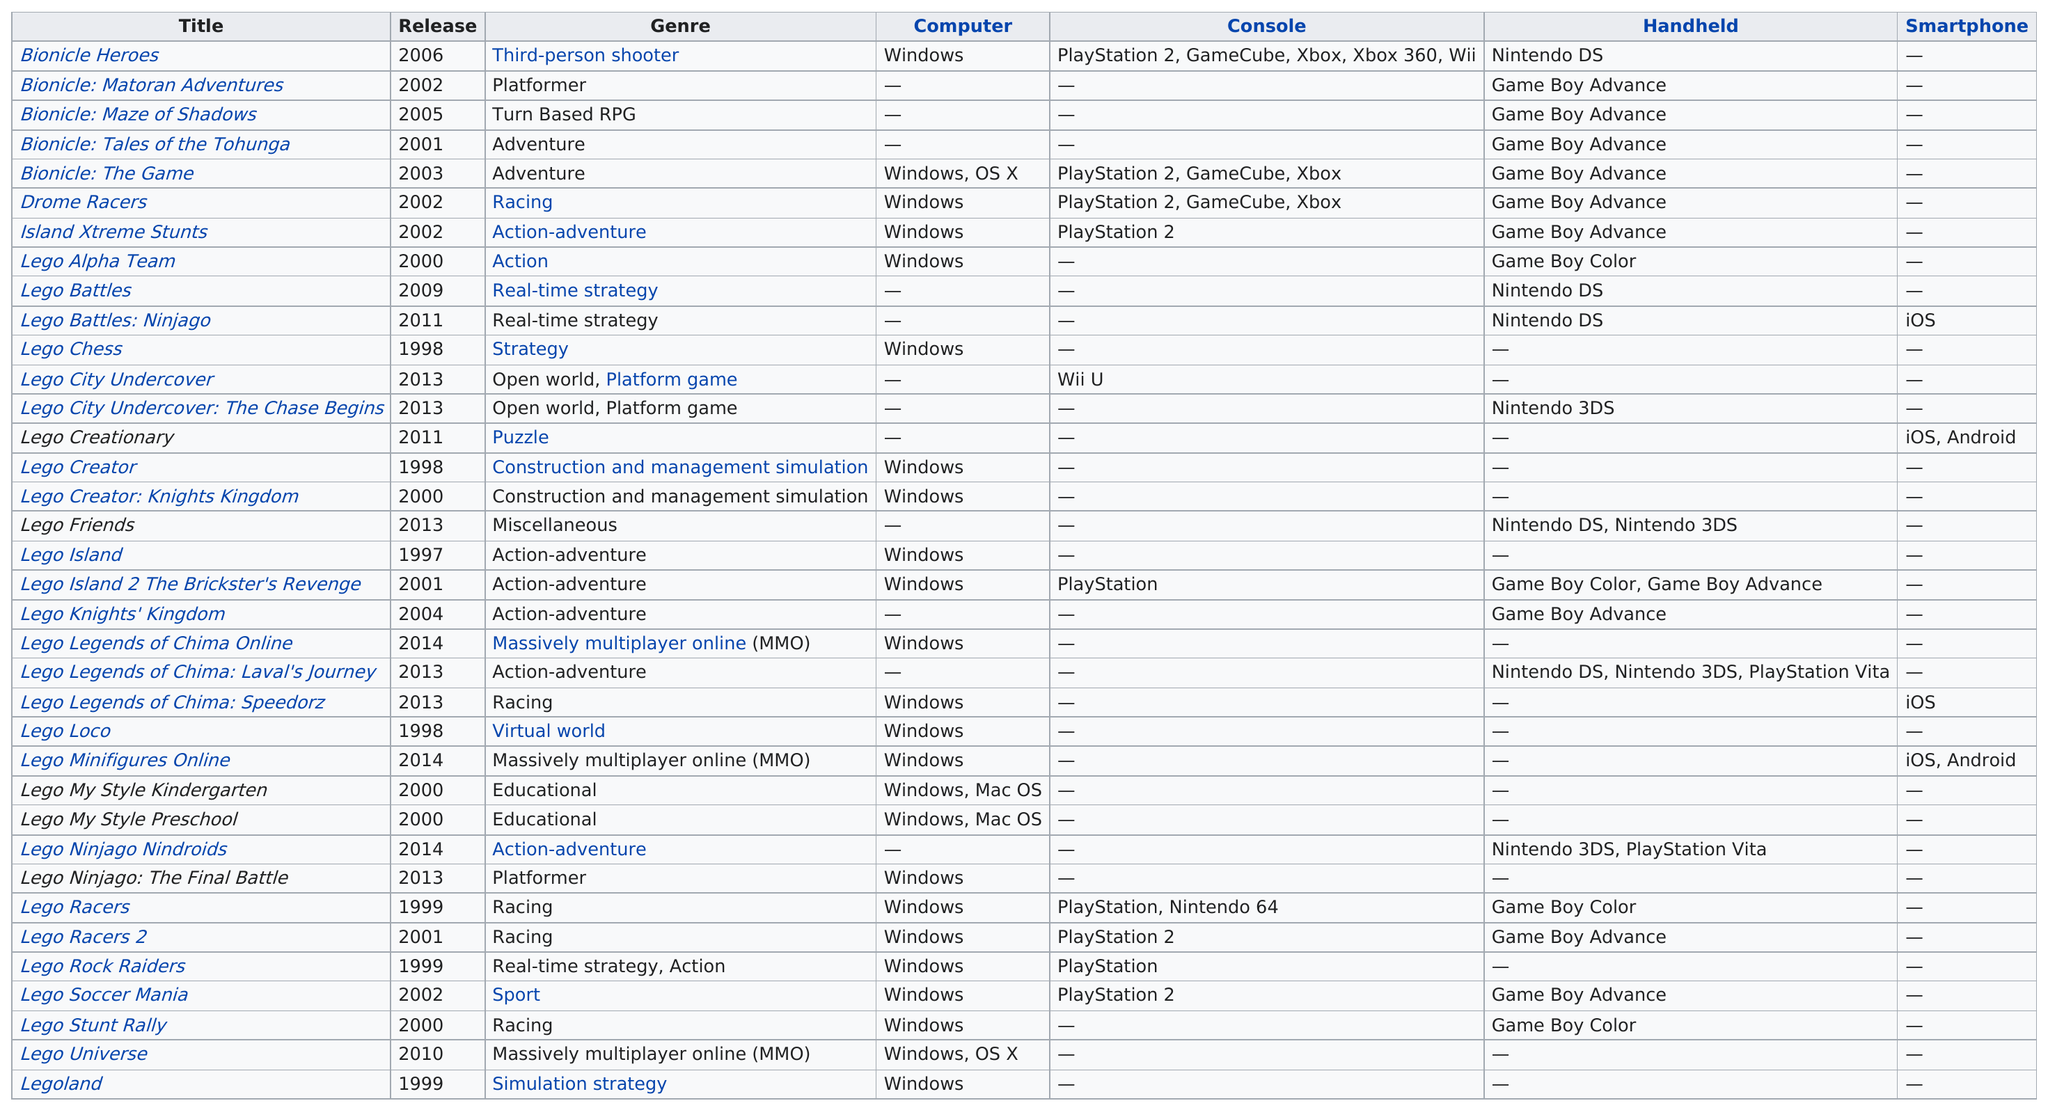Specify some key components in this picture. As of 1998, there were only three games released. Lego Creationary can be played on two types of smartphones. I regret to inform you that the game "Bionicle: The Game" is not playable on the Wii console. The first game released was Lego Island. The majority of games can be played on Windows-based computers. 